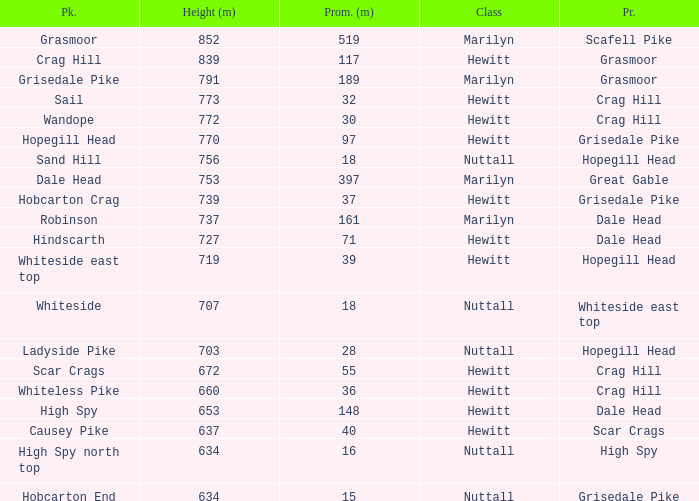Which Parent has height smaller than 756 and a Prom of 39? Hopegill Head. 